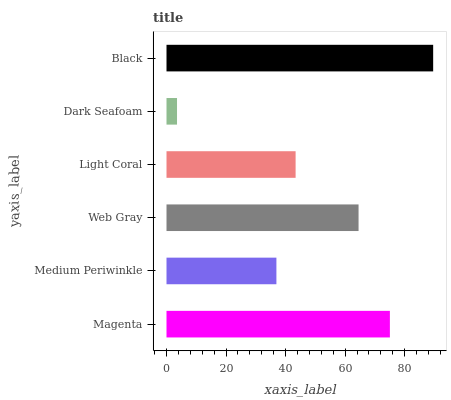Is Dark Seafoam the minimum?
Answer yes or no. Yes. Is Black the maximum?
Answer yes or no. Yes. Is Medium Periwinkle the minimum?
Answer yes or no. No. Is Medium Periwinkle the maximum?
Answer yes or no. No. Is Magenta greater than Medium Periwinkle?
Answer yes or no. Yes. Is Medium Periwinkle less than Magenta?
Answer yes or no. Yes. Is Medium Periwinkle greater than Magenta?
Answer yes or no. No. Is Magenta less than Medium Periwinkle?
Answer yes or no. No. Is Web Gray the high median?
Answer yes or no. Yes. Is Light Coral the low median?
Answer yes or no. Yes. Is Light Coral the high median?
Answer yes or no. No. Is Black the low median?
Answer yes or no. No. 